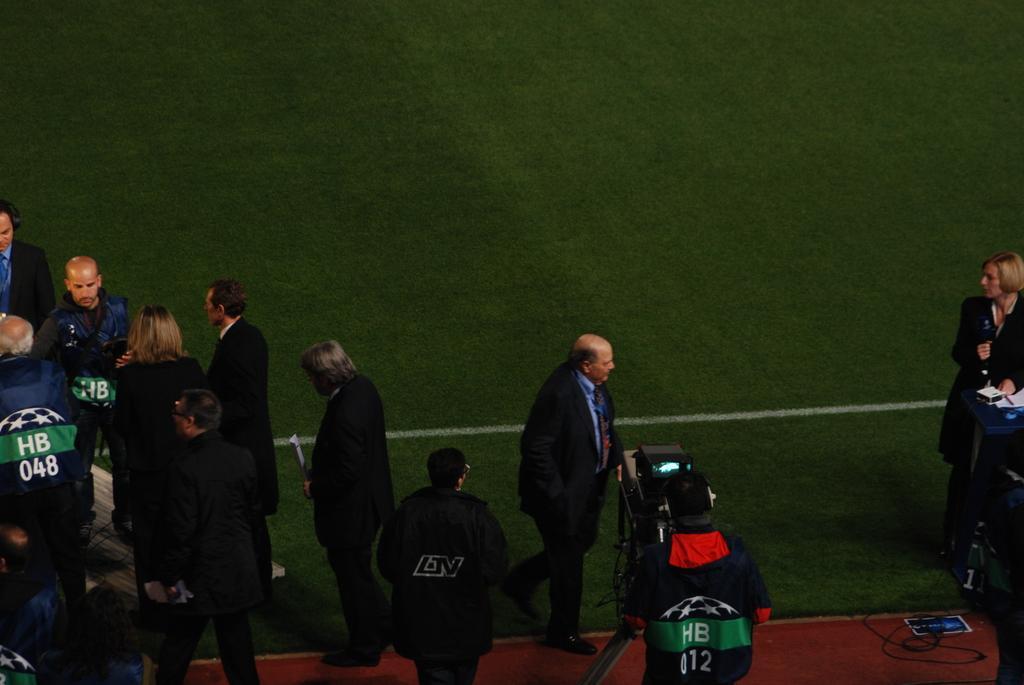Please provide a concise description of this image. On the left side, there are persons on the ground. On the right side, there is a person in a suit, walking. Beside him, there is a person holding a camera which is on a stand. And there are other two persons on the ground, on which there is a white color line and there is grass. 